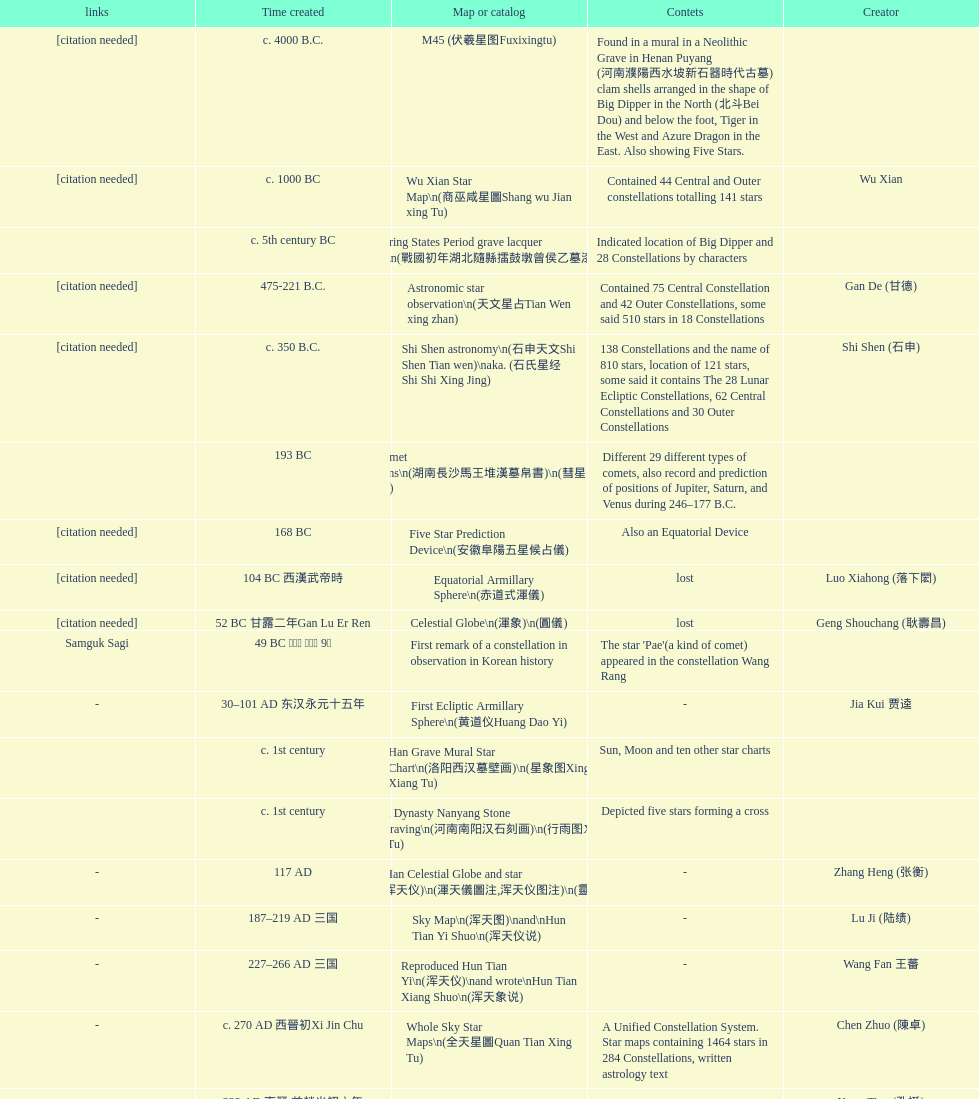Which star map was created earlier, celestial globe or the han grave mural star chart? Celestial Globe. 